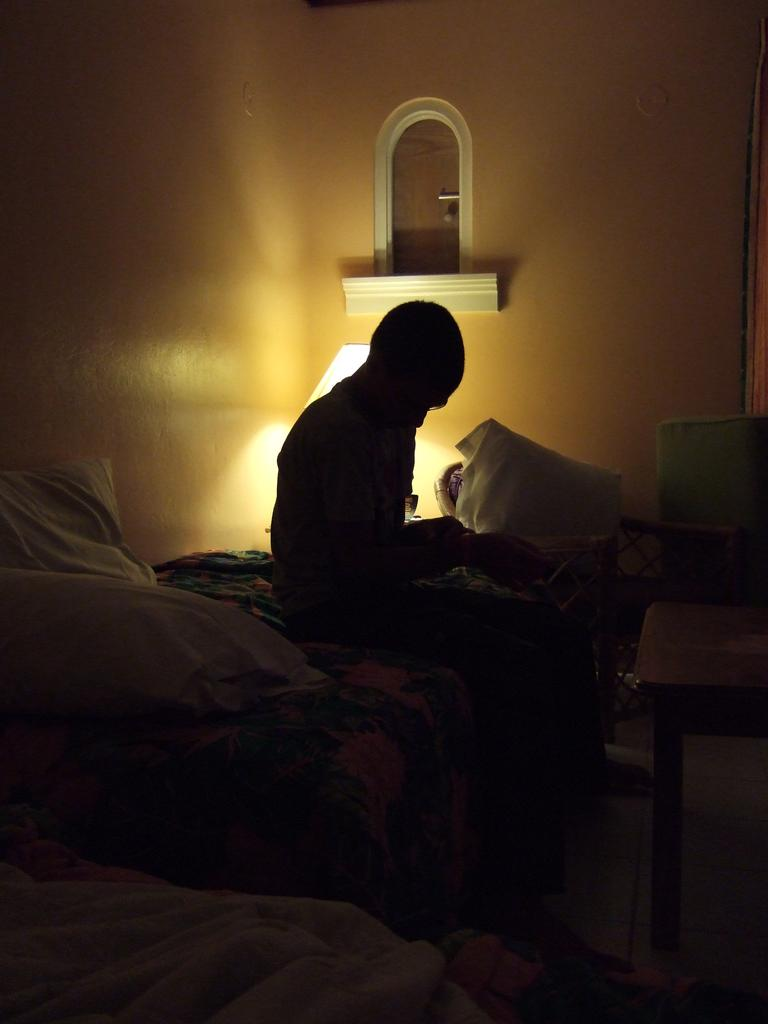What is the lighting condition in the image? The image is taken in a dark environment. What is the person in the image doing? There is a person sitting on the bed. What can be seen on the bed besides the person? There are pillows on the bed. What furniture is present in the room? There is a table in the room. What is used to provide light in the room? A table lamp is present on the table. What is fixed to the wall in the room? There is a mirror fixed to the wall. What type of rod can be seen in the image? There is no rod present in the image. What is the person's nose doing in the image? The person's nose is not doing anything in the image; it is simply a part of their face. 